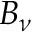<formula> <loc_0><loc_0><loc_500><loc_500>B _ { \nu }</formula> 